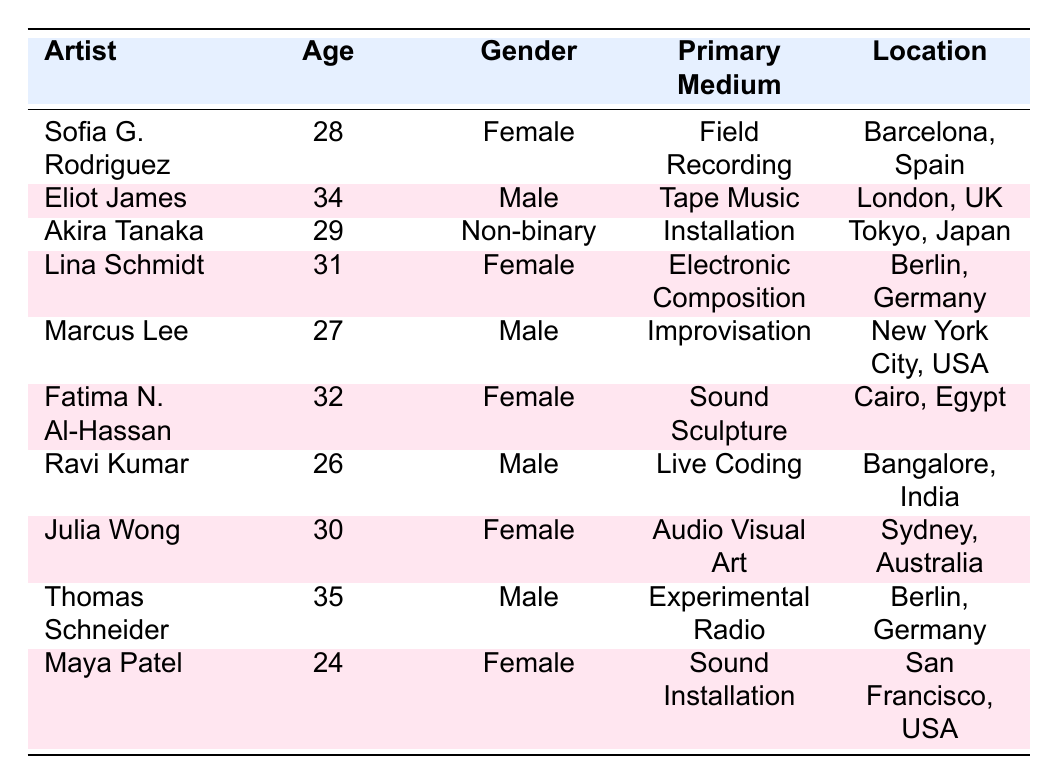What is the primary medium of Maya Patel? The table lists Maya Patel under the "Primary Medium" column, which states her medium as "Sound Installation."
Answer: Sound Installation How many years has Eliot James been active as an artist? According to the table, Eliot James has "10" years listed under the "Years Active" column.
Answer: 10 Which artist from the table is located in Berlin, Germany? The table contains two entries for artists located in Berlin: Lina Schmidt and Thomas Schneider.
Answer: Lina Schmidt and Thomas Schneider Is there a male artist aged 30 or younger in the table? The only male artist aged 30 or younger is Ravi Kumar, who is 26 years old.
Answer: Yes What is the average age of the artists listed in the table? The ages of the artists are 28, 34, 29, 31, 27, 32, 26, 30, 35, and 24. The sum is 28 + 34 + 29 + 31 + 27 + 32 + 26 + 30 + 35 + 24 =  30. The average is 30/10 = 30.
Answer: 30 How many female artists are represented in the table? The table shows the artist gender for Sofia G. Rodriguez, Lina Schmidt, Fatima N. Al-Hassan, Julia Wong, and Maya Patel, totaling 5 female artists.
Answer: 5 Who has a Master's degree among the artists? From the table, Sofia G. Rodriguez and Fatima N. Al-Hassan hold Master's degrees as indicated in the "Education" column.
Answer: Sofia G. Rodriguez and Fatima N. Al-Hassan Which medium has the youngest average age of artists? To find the average age of artists by medium, we calculate ages for each medium. For Field Recording (28), Tape Music (34), Installation (29), Electronic Composition (31), Improvisation (27), Sound Sculpture (32), Live Coding (26), Audio Visual Art (30), Experimental Radio (35), and Sound Installation (24). The average for Sound Installation is 24; hence, it is the youngest.
Answer: Sound Installation Are there any artists with a Bachelor’s degree in the table? Upon reviewing the education column, there are several artists with Bachelor's degrees: Eliot James, Lina Schmidt, Marcus Lee, and Maya Patel.
Answer: Yes Who is the oldest artist in the table? The oldest artist is Thomas Schneider, who is listed as 35 years old in the age column.
Answer: Thomas Schneider 